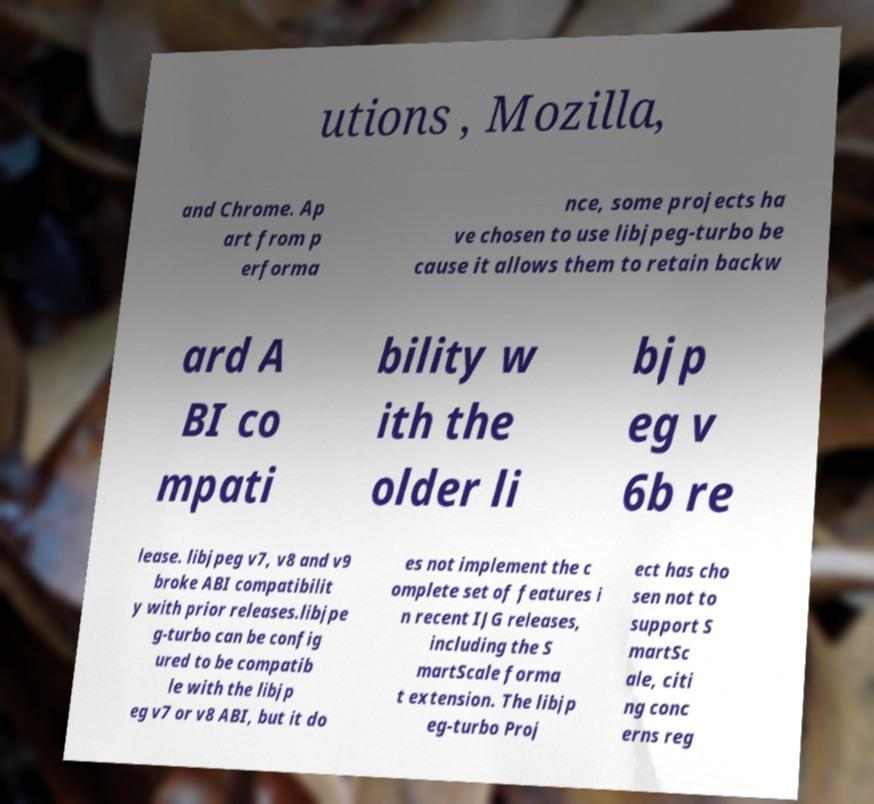Can you accurately transcribe the text from the provided image for me? utions , Mozilla, and Chrome. Ap art from p erforma nce, some projects ha ve chosen to use libjpeg-turbo be cause it allows them to retain backw ard A BI co mpati bility w ith the older li bjp eg v 6b re lease. libjpeg v7, v8 and v9 broke ABI compatibilit y with prior releases.libjpe g-turbo can be config ured to be compatib le with the libjp eg v7 or v8 ABI, but it do es not implement the c omplete set of features i n recent IJG releases, including the S martScale forma t extension. The libjp eg-turbo Proj ect has cho sen not to support S martSc ale, citi ng conc erns reg 